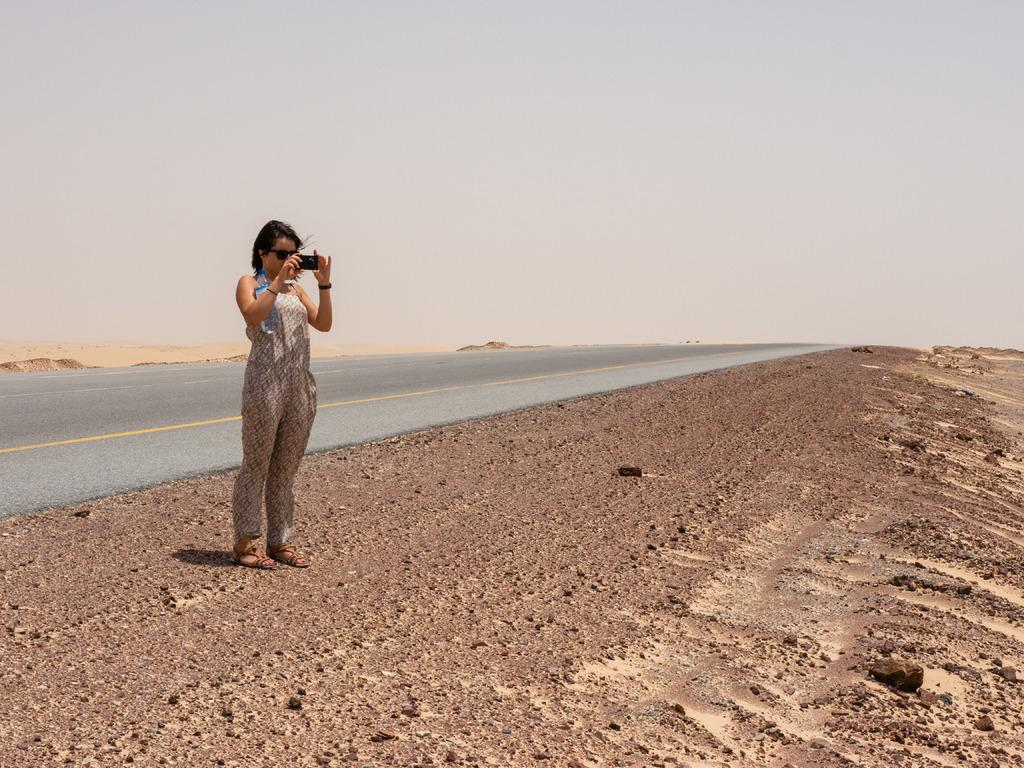What is the person in the image doing? The person is standing in the image and holding a mobile. What can be seen in the background of the image? The sky is visible in the background of the image. What is the color of the sky in the image? The color of the sky is white. How many nails can be seen in the image? There are no nails present in the image. What causes the sky to burst in the image? The sky does not burst in the image; it is simply white. 